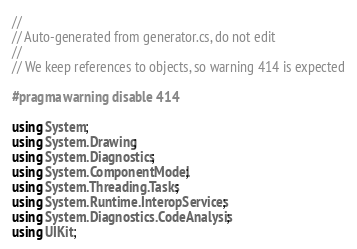Convert code to text. <code><loc_0><loc_0><loc_500><loc_500><_C#_>//
// Auto-generated from generator.cs, do not edit
//
// We keep references to objects, so warning 414 is expected

#pragma warning disable 414

using System;
using System.Drawing;
using System.Diagnostics;
using System.ComponentModel;
using System.Threading.Tasks;
using System.Runtime.InteropServices;
using System.Diagnostics.CodeAnalysis;
using UIKit;</code> 